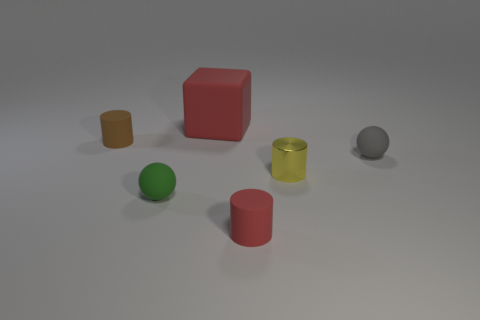Is there anything else that has the same size as the red cube?
Keep it short and to the point. No. The tiny rubber thing that is in front of the brown rubber object and left of the block is what color?
Offer a terse response. Green. The tiny gray object that is made of the same material as the tiny green ball is what shape?
Provide a short and direct response. Sphere. How many tiny objects are both to the left of the small yellow shiny object and behind the small green rubber thing?
Your answer should be very brief. 1. There is a yellow metal object; are there any small gray rubber objects in front of it?
Offer a very short reply. No. Do the red object that is behind the small gray object and the object that is to the left of the green ball have the same shape?
Keep it short and to the point. No. How many things are red cubes or red rubber things behind the small yellow metallic thing?
Offer a terse response. 1. How many other things are the same shape as the small gray thing?
Your answer should be compact. 1. Is the sphere to the right of the large thing made of the same material as the small yellow cylinder?
Offer a terse response. No. How many objects are either big cubes or big metal blocks?
Ensure brevity in your answer.  1. 